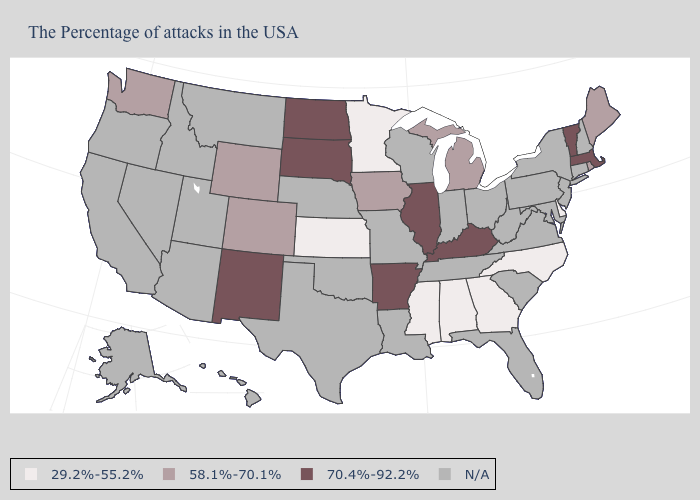Which states have the lowest value in the MidWest?
Short answer required. Minnesota, Kansas. Name the states that have a value in the range 29.2%-55.2%?
Short answer required. Delaware, North Carolina, Georgia, Alabama, Mississippi, Minnesota, Kansas. Name the states that have a value in the range 58.1%-70.1%?
Give a very brief answer. Maine, Rhode Island, Michigan, Iowa, Wyoming, Colorado, Washington. Which states have the lowest value in the South?
Write a very short answer. Delaware, North Carolina, Georgia, Alabama, Mississippi. Which states have the lowest value in the USA?
Quick response, please. Delaware, North Carolina, Georgia, Alabama, Mississippi, Minnesota, Kansas. Is the legend a continuous bar?
Give a very brief answer. No. Name the states that have a value in the range N/A?
Give a very brief answer. New Hampshire, Connecticut, New York, New Jersey, Maryland, Pennsylvania, Virginia, South Carolina, West Virginia, Ohio, Florida, Indiana, Tennessee, Wisconsin, Louisiana, Missouri, Nebraska, Oklahoma, Texas, Utah, Montana, Arizona, Idaho, Nevada, California, Oregon, Alaska, Hawaii. Does the first symbol in the legend represent the smallest category?
Concise answer only. Yes. Which states have the highest value in the USA?
Concise answer only. Massachusetts, Vermont, Kentucky, Illinois, Arkansas, South Dakota, North Dakota, New Mexico. Name the states that have a value in the range 58.1%-70.1%?
Keep it brief. Maine, Rhode Island, Michigan, Iowa, Wyoming, Colorado, Washington. What is the value of Michigan?
Answer briefly. 58.1%-70.1%. Does Vermont have the highest value in the Northeast?
Concise answer only. Yes. What is the value of West Virginia?
Give a very brief answer. N/A. What is the lowest value in the USA?
Quick response, please. 29.2%-55.2%. 